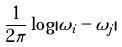Convert formula to latex. <formula><loc_0><loc_0><loc_500><loc_500>\frac { 1 } { 2 \pi } \log | \omega _ { i } - \omega _ { j } |</formula> 